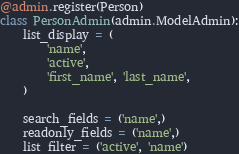Convert code to text. <code><loc_0><loc_0><loc_500><loc_500><_Python_>

@admin.register(Person)
class PersonAdmin(admin.ModelAdmin):
    list_display = (
        'name',
        'active',
        'first_name', 'last_name',
    )

    search_fields = ('name',)
    readonly_fields = ('name',)
    list_filter = ('active', 'name')
</code> 